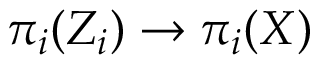Convert formula to latex. <formula><loc_0><loc_0><loc_500><loc_500>\pi _ { i } ( Z _ { i } ) \to \pi _ { i } ( X )</formula> 